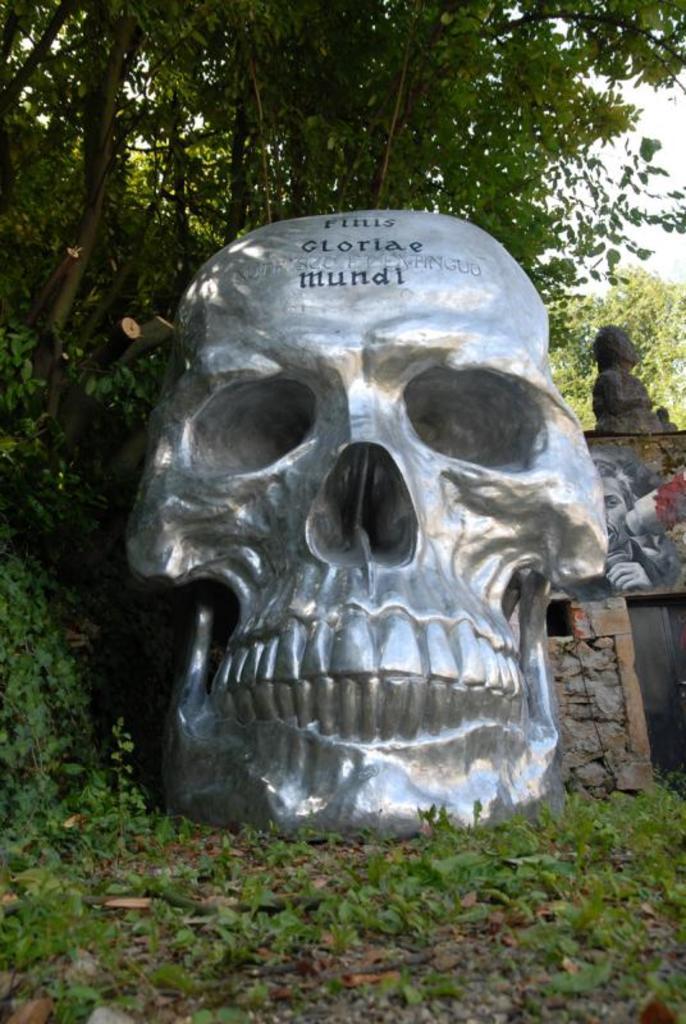Please provide a concise description of this image. In the picture we can see the skull sculpture on the grass. In the background, we can see a photo frame, statue and trees. 